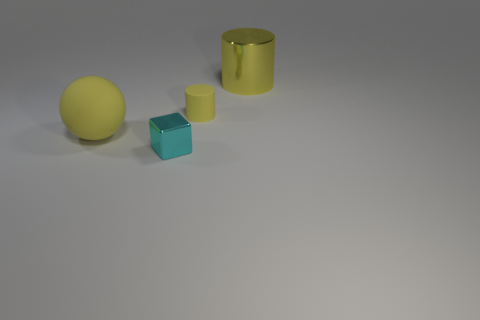Add 3 red things. How many objects exist? 7 Subtract all balls. How many objects are left? 3 Subtract all large metal cylinders. Subtract all small yellow matte cylinders. How many objects are left? 2 Add 1 big cylinders. How many big cylinders are left? 2 Add 2 blue shiny cylinders. How many blue shiny cylinders exist? 2 Subtract 0 gray cylinders. How many objects are left? 4 